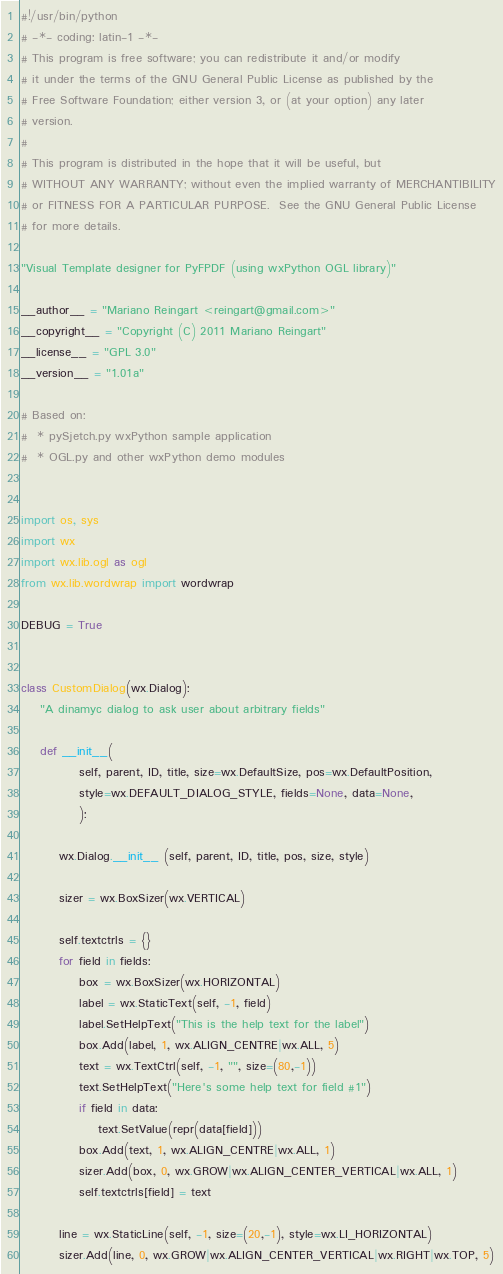<code> <loc_0><loc_0><loc_500><loc_500><_Python_>#!/usr/bin/python
# -*- coding: latin-1 -*-
# This program is free software; you can redistribute it and/or modify
# it under the terms of the GNU General Public License as published by the
# Free Software Foundation; either version 3, or (at your option) any later
# version.
#
# This program is distributed in the hope that it will be useful, but
# WITHOUT ANY WARRANTY; without even the implied warranty of MERCHANTIBILITY
# or FITNESS FOR A PARTICULAR PURPOSE.  See the GNU General Public License
# for more details.

"Visual Template designer for PyFPDF (using wxPython OGL library)"

__author__ = "Mariano Reingart <reingart@gmail.com>"
__copyright__ = "Copyright (C) 2011 Mariano Reingart"
__license__ = "GPL 3.0"
__version__ = "1.01a"

# Based on:
#  * pySjetch.py wxPython sample application
#  * OGL.py and other wxPython demo modules


import os, sys
import wx
import wx.lib.ogl as ogl
from wx.lib.wordwrap import wordwrap

DEBUG = True


class CustomDialog(wx.Dialog):
    "A dinamyc dialog to ask user about arbitrary fields"

    def __init__(
            self, parent, ID, title, size=wx.DefaultSize, pos=wx.DefaultPosition,
            style=wx.DEFAULT_DIALOG_STYLE, fields=None, data=None,
            ):

        wx.Dialog.__init__ (self, parent, ID, title, pos, size, style)

        sizer = wx.BoxSizer(wx.VERTICAL)

        self.textctrls = {}
        for field in fields:
            box = wx.BoxSizer(wx.HORIZONTAL)
            label = wx.StaticText(self, -1, field)
            label.SetHelpText("This is the help text for the label")
            box.Add(label, 1, wx.ALIGN_CENTRE|wx.ALL, 5)
            text = wx.TextCtrl(self, -1, "", size=(80,-1))
            text.SetHelpText("Here's some help text for field #1")
            if field in data:
                text.SetValue(repr(data[field]))
            box.Add(text, 1, wx.ALIGN_CENTRE|wx.ALL, 1)
            sizer.Add(box, 0, wx.GROW|wx.ALIGN_CENTER_VERTICAL|wx.ALL, 1)
            self.textctrls[field] = text

        line = wx.StaticLine(self, -1, size=(20,-1), style=wx.LI_HORIZONTAL)
        sizer.Add(line, 0, wx.GROW|wx.ALIGN_CENTER_VERTICAL|wx.RIGHT|wx.TOP, 5)
</code> 